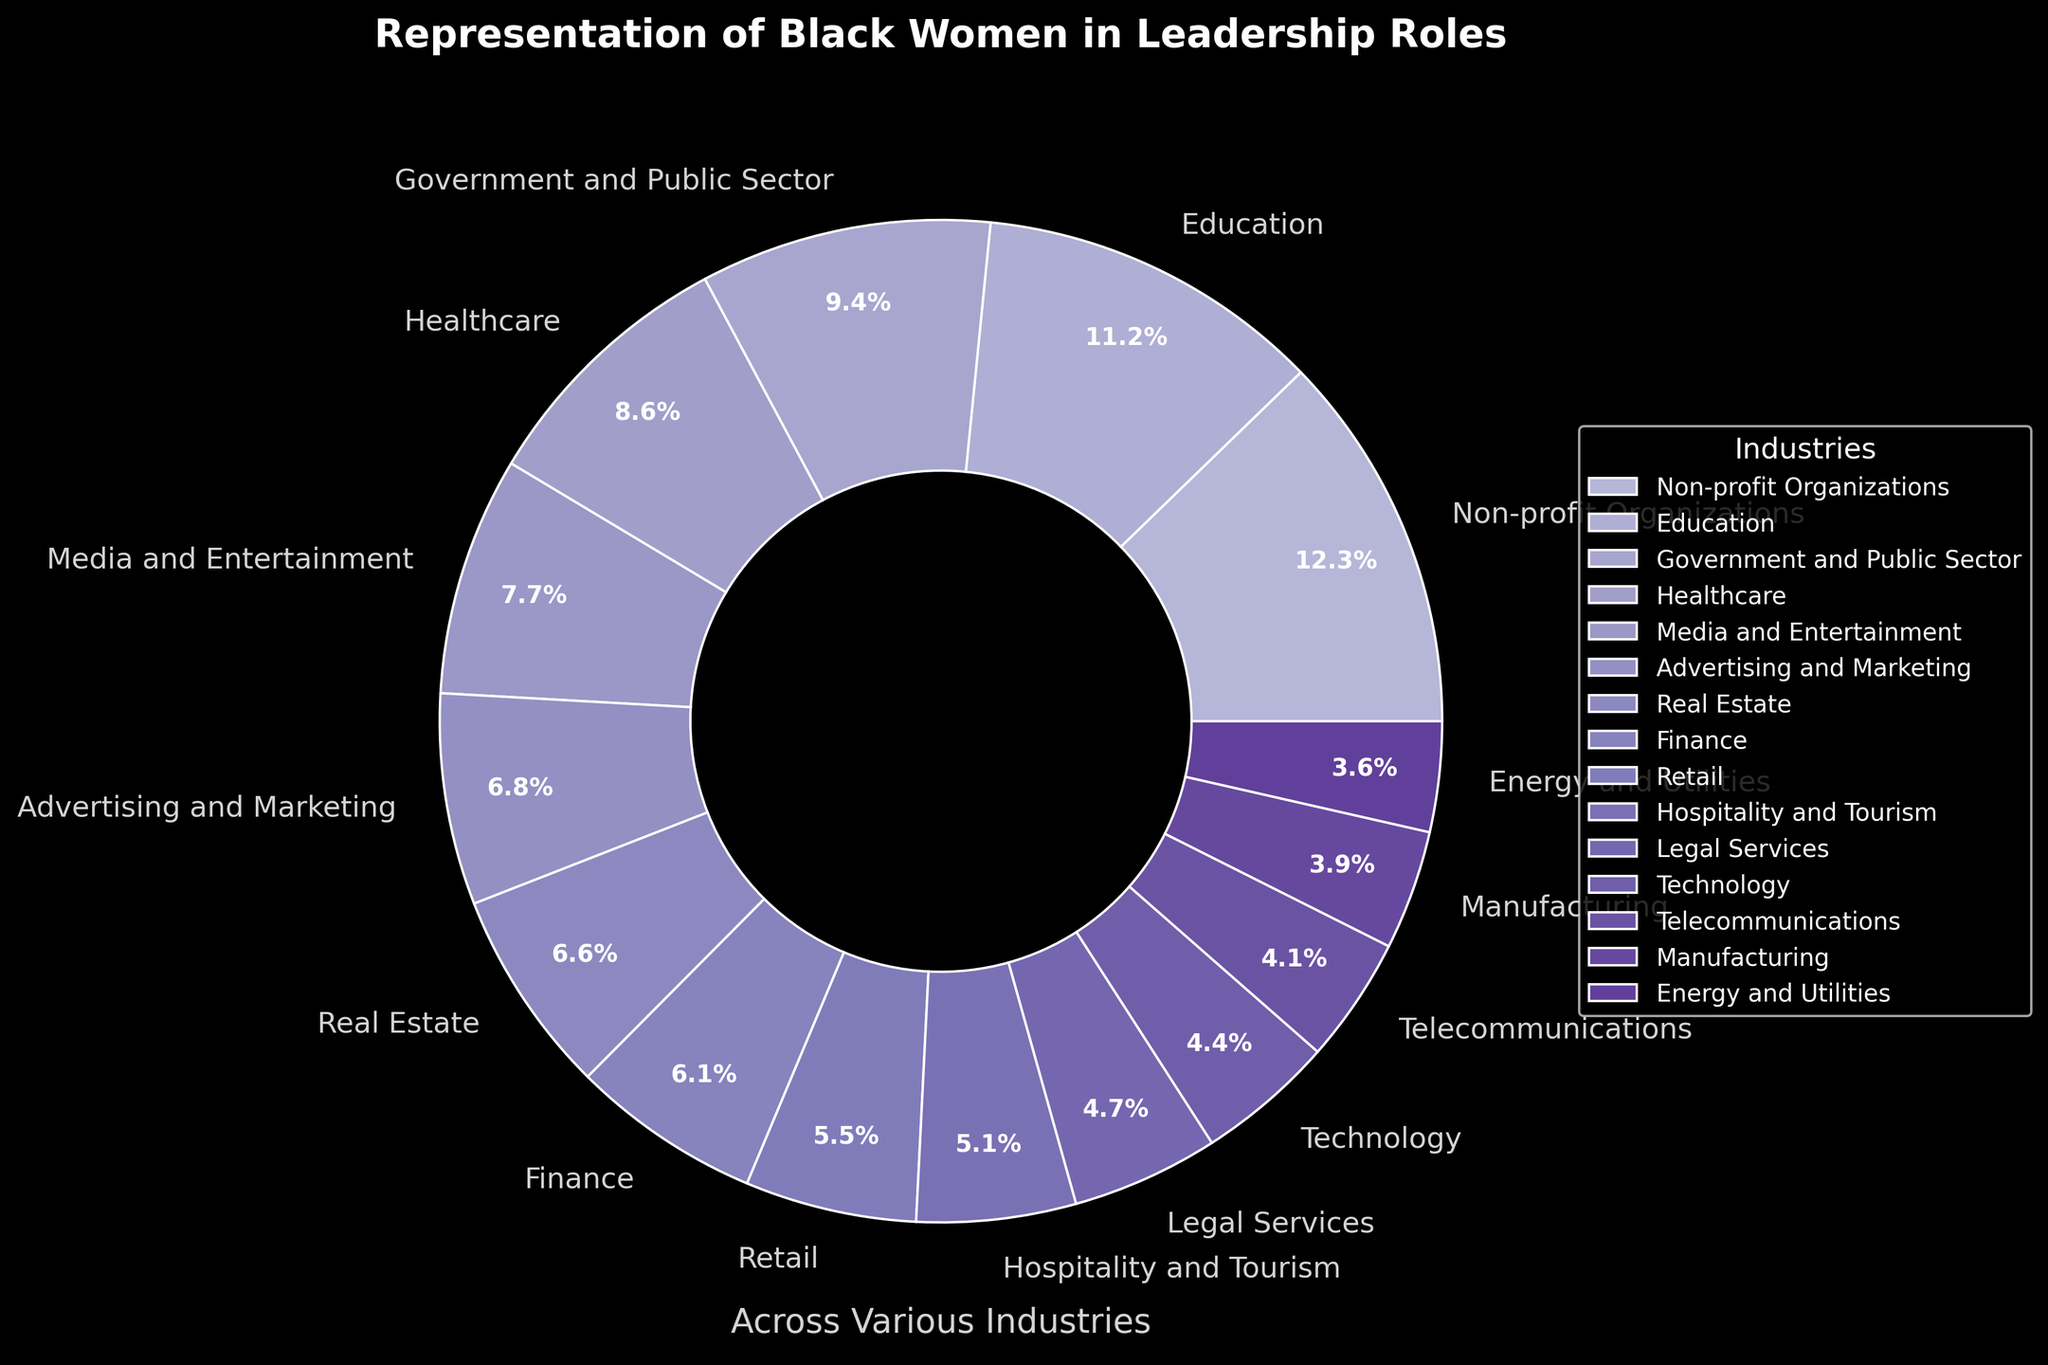What's the industry with the highest representation of black women in leadership roles? The industry with the highest representation is shown by the largest segment of the pie chart. According to the visual, the largest segment corresponds to Non-profit Organizations.
Answer: Non-profit Organizations Which industry has a smaller percentage representation, Manufacturing or Legal Services? By comparing the sizes of the segments labeled Manufacturing and Legal Services, Manufacturing is smaller. Manufacturing has a percentage of 3.9% while Legal Services has 4.8%.
Answer: Manufacturing What is the combined representation of black women in leadership roles in Technology and Telecommunications industries? Add the percentages of Technology (4.5%) and Telecommunications (4.1%). The combined representation is 4.5% + 4.1%.
Answer: 8.6% Is the representation of black women in Media and Entertainment greater than in Hospitality and Tourism? Compare the percentages of Media and Entertainment (7.8%) and Hospitality and Tourism (5.2%). Since 7.8% is greater than 5.2%, Media and Entertainment has a greater representation.
Answer: Yes What is the average representation percentage across all listed industries? Calculate the average by summing all the percentages and dividing by the number of industries: (4.5 + 6.2 + 8.7 + 11.3 + 7.8 + 9.5 + 5.6 + 3.9 + 4.8 + 12.4 + 6.7 + 5.2 + 4.1 + 3.6 + 6.9) / 15. The sum is 100.2% and dividing by 15 gives the average.
Answer: 6.68% How does the representation in Education compare to the Government and Public Sector? Compare the segments labeled Education (11.3%) and Government and Public Sector (9.5%). Education has a higher percentage than Government and Public Sector.
Answer: Education has higher representation What industries have a representation less than 5%? Identify segments with percentages less than 5%: Technology (4.5%), Manufacturing (3.9%), Telecommunications (4.1%), and Energy and Utilities (3.6%).
Answer: Technology, Manufacturing, Telecommunications, Energy and Utilities Which industries have a combined representation percentage greater than 20%? Sum the representations of industries and see which combinations exceed 20%. Non-profit Organizations (12.4%) and Education (11.3%) together is 23.7%. This is one possible combination.
Answer: Non-profit Organizations and Education 